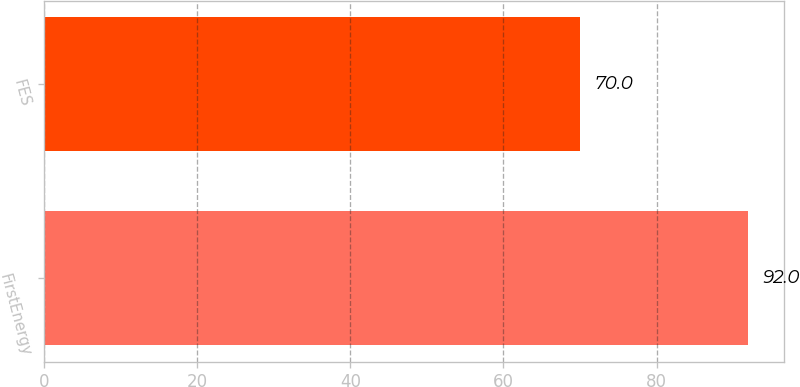Convert chart. <chart><loc_0><loc_0><loc_500><loc_500><bar_chart><fcel>FirstEnergy<fcel>FES<nl><fcel>92<fcel>70<nl></chart> 